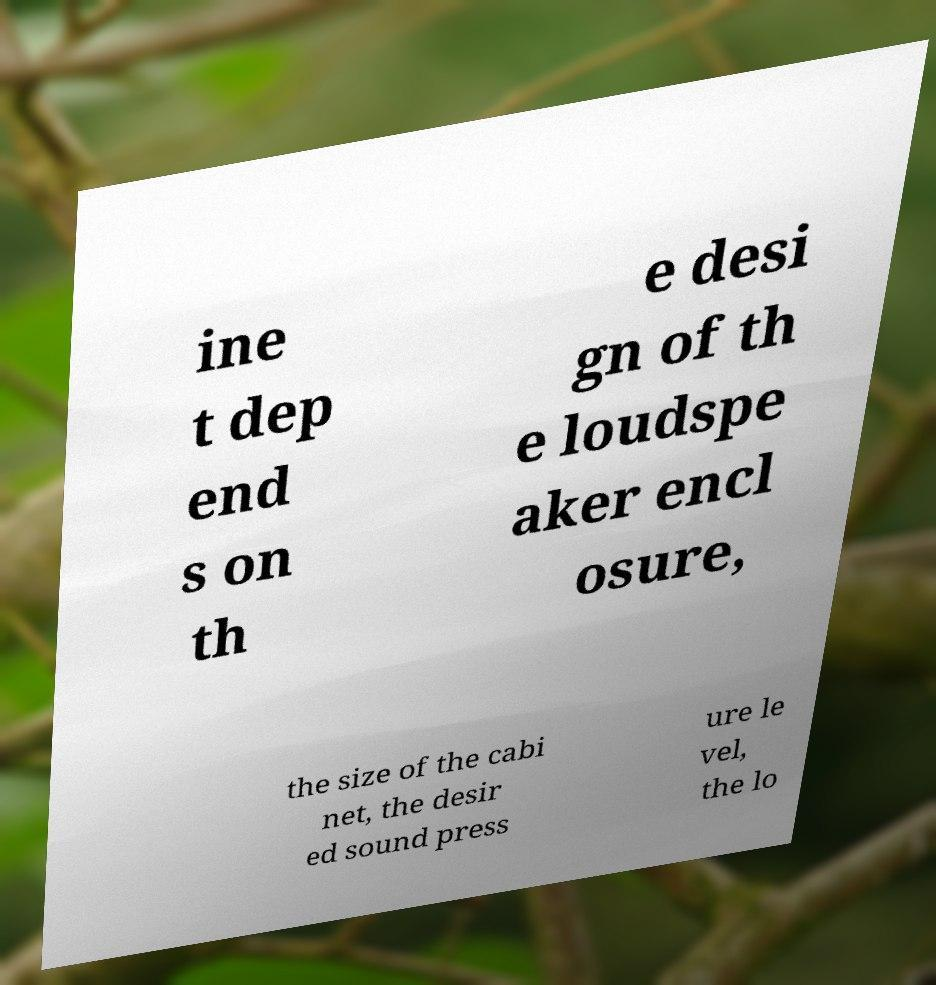What messages or text are displayed in this image? I need them in a readable, typed format. ine t dep end s on th e desi gn of th e loudspe aker encl osure, the size of the cabi net, the desir ed sound press ure le vel, the lo 